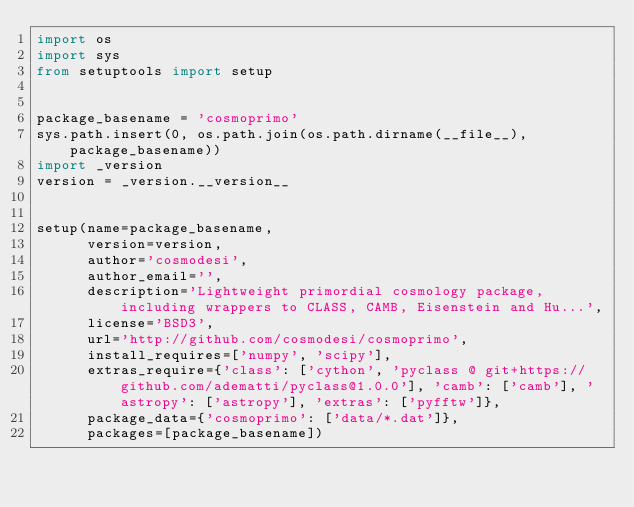<code> <loc_0><loc_0><loc_500><loc_500><_Python_>import os
import sys
from setuptools import setup


package_basename = 'cosmoprimo'
sys.path.insert(0, os.path.join(os.path.dirname(__file__), package_basename))
import _version
version = _version.__version__


setup(name=package_basename,
      version=version,
      author='cosmodesi',
      author_email='',
      description='Lightweight primordial cosmology package, including wrappers to CLASS, CAMB, Eisenstein and Hu...',
      license='BSD3',
      url='http://github.com/cosmodesi/cosmoprimo',
      install_requires=['numpy', 'scipy'],
      extras_require={'class': ['cython', 'pyclass @ git+https://github.com/adematti/pyclass@1.0.0'], 'camb': ['camb'], 'astropy': ['astropy'], 'extras': ['pyfftw']},
      package_data={'cosmoprimo': ['data/*.dat']},
      packages=[package_basename])
</code> 